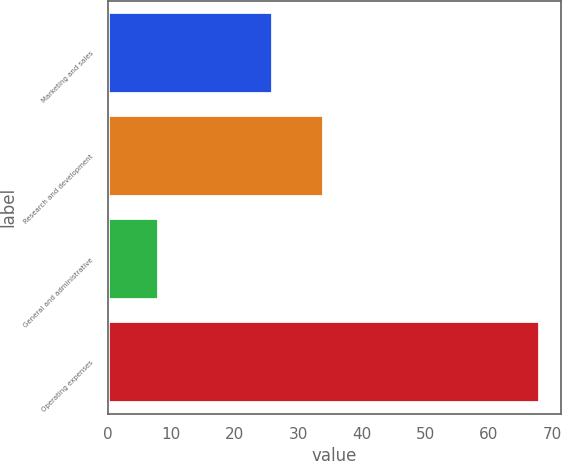<chart> <loc_0><loc_0><loc_500><loc_500><bar_chart><fcel>Marketing and sales<fcel>Research and development<fcel>General and administrative<fcel>Operating expenses<nl><fcel>26<fcel>34<fcel>8<fcel>68<nl></chart> 